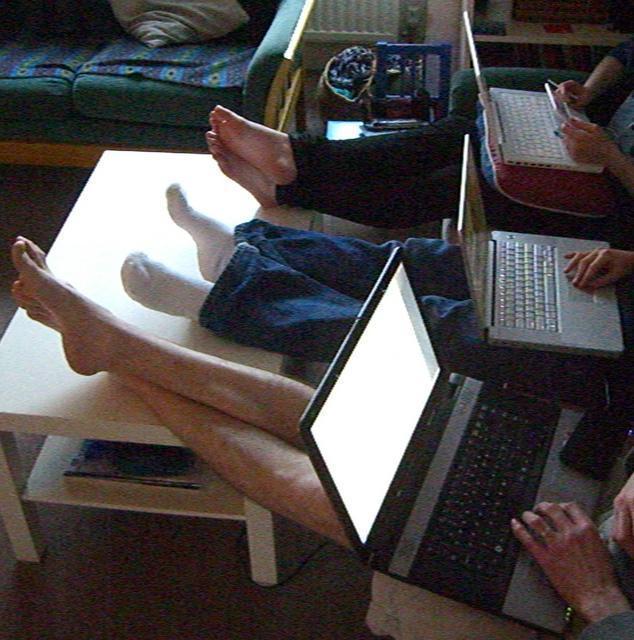How many people are wearing socks?
Give a very brief answer. 1. How many couches can be seen?
Give a very brief answer. 2. How many laptops are there?
Give a very brief answer. 3. How many people are there?
Give a very brief answer. 3. How many holes are in the toilet bowl?
Give a very brief answer. 0. 